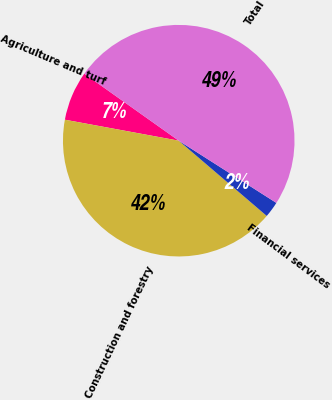Convert chart to OTSL. <chart><loc_0><loc_0><loc_500><loc_500><pie_chart><fcel>Agriculture and turf<fcel>Construction and forestry<fcel>Financial services<fcel>Total<nl><fcel>6.92%<fcel>41.64%<fcel>2.23%<fcel>49.21%<nl></chart> 